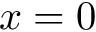<formula> <loc_0><loc_0><loc_500><loc_500>x = 0</formula> 